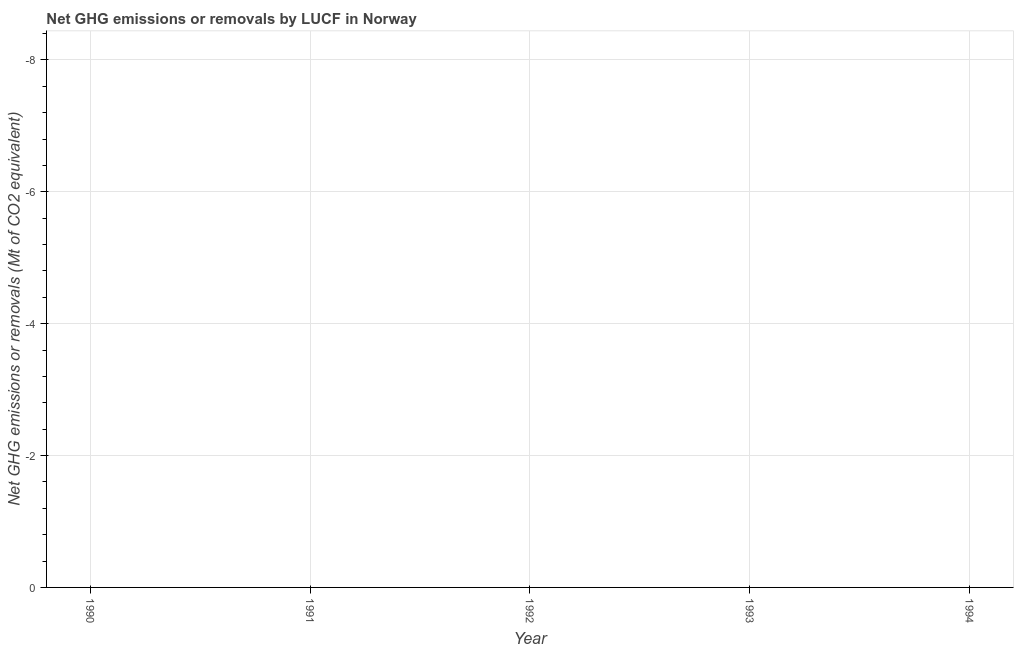Across all years, what is the minimum ghg net emissions or removals?
Provide a short and direct response. 0. What is the average ghg net emissions or removals per year?
Ensure brevity in your answer.  0. In how many years, is the ghg net emissions or removals greater than -4.8 Mt?
Provide a short and direct response. 0. Are the values on the major ticks of Y-axis written in scientific E-notation?
Provide a short and direct response. No. Does the graph contain grids?
Your answer should be very brief. Yes. What is the title of the graph?
Offer a very short reply. Net GHG emissions or removals by LUCF in Norway. What is the label or title of the X-axis?
Ensure brevity in your answer.  Year. What is the label or title of the Y-axis?
Offer a terse response. Net GHG emissions or removals (Mt of CO2 equivalent). What is the Net GHG emissions or removals (Mt of CO2 equivalent) in 1990?
Make the answer very short. 0. 